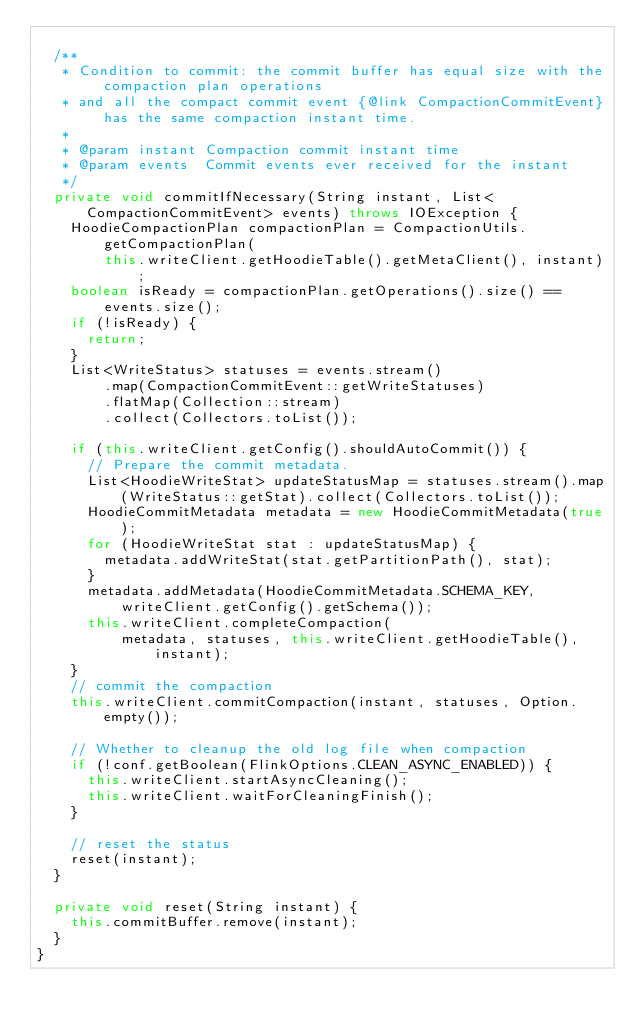Convert code to text. <code><loc_0><loc_0><loc_500><loc_500><_Java_>
  /**
   * Condition to commit: the commit buffer has equal size with the compaction plan operations
   * and all the compact commit event {@link CompactionCommitEvent} has the same compaction instant time.
   *
   * @param instant Compaction commit instant time
   * @param events  Commit events ever received for the instant
   */
  private void commitIfNecessary(String instant, List<CompactionCommitEvent> events) throws IOException {
    HoodieCompactionPlan compactionPlan = CompactionUtils.getCompactionPlan(
        this.writeClient.getHoodieTable().getMetaClient(), instant);
    boolean isReady = compactionPlan.getOperations().size() == events.size();
    if (!isReady) {
      return;
    }
    List<WriteStatus> statuses = events.stream()
        .map(CompactionCommitEvent::getWriteStatuses)
        .flatMap(Collection::stream)
        .collect(Collectors.toList());

    if (this.writeClient.getConfig().shouldAutoCommit()) {
      // Prepare the commit metadata.
      List<HoodieWriteStat> updateStatusMap = statuses.stream().map(WriteStatus::getStat).collect(Collectors.toList());
      HoodieCommitMetadata metadata = new HoodieCommitMetadata(true);
      for (HoodieWriteStat stat : updateStatusMap) {
        metadata.addWriteStat(stat.getPartitionPath(), stat);
      }
      metadata.addMetadata(HoodieCommitMetadata.SCHEMA_KEY, writeClient.getConfig().getSchema());
      this.writeClient.completeCompaction(
          metadata, statuses, this.writeClient.getHoodieTable(), instant);
    }
    // commit the compaction
    this.writeClient.commitCompaction(instant, statuses, Option.empty());

    // Whether to cleanup the old log file when compaction
    if (!conf.getBoolean(FlinkOptions.CLEAN_ASYNC_ENABLED)) {
      this.writeClient.startAsyncCleaning();
      this.writeClient.waitForCleaningFinish();
    }

    // reset the status
    reset(instant);
  }

  private void reset(String instant) {
    this.commitBuffer.remove(instant);
  }
}
</code> 